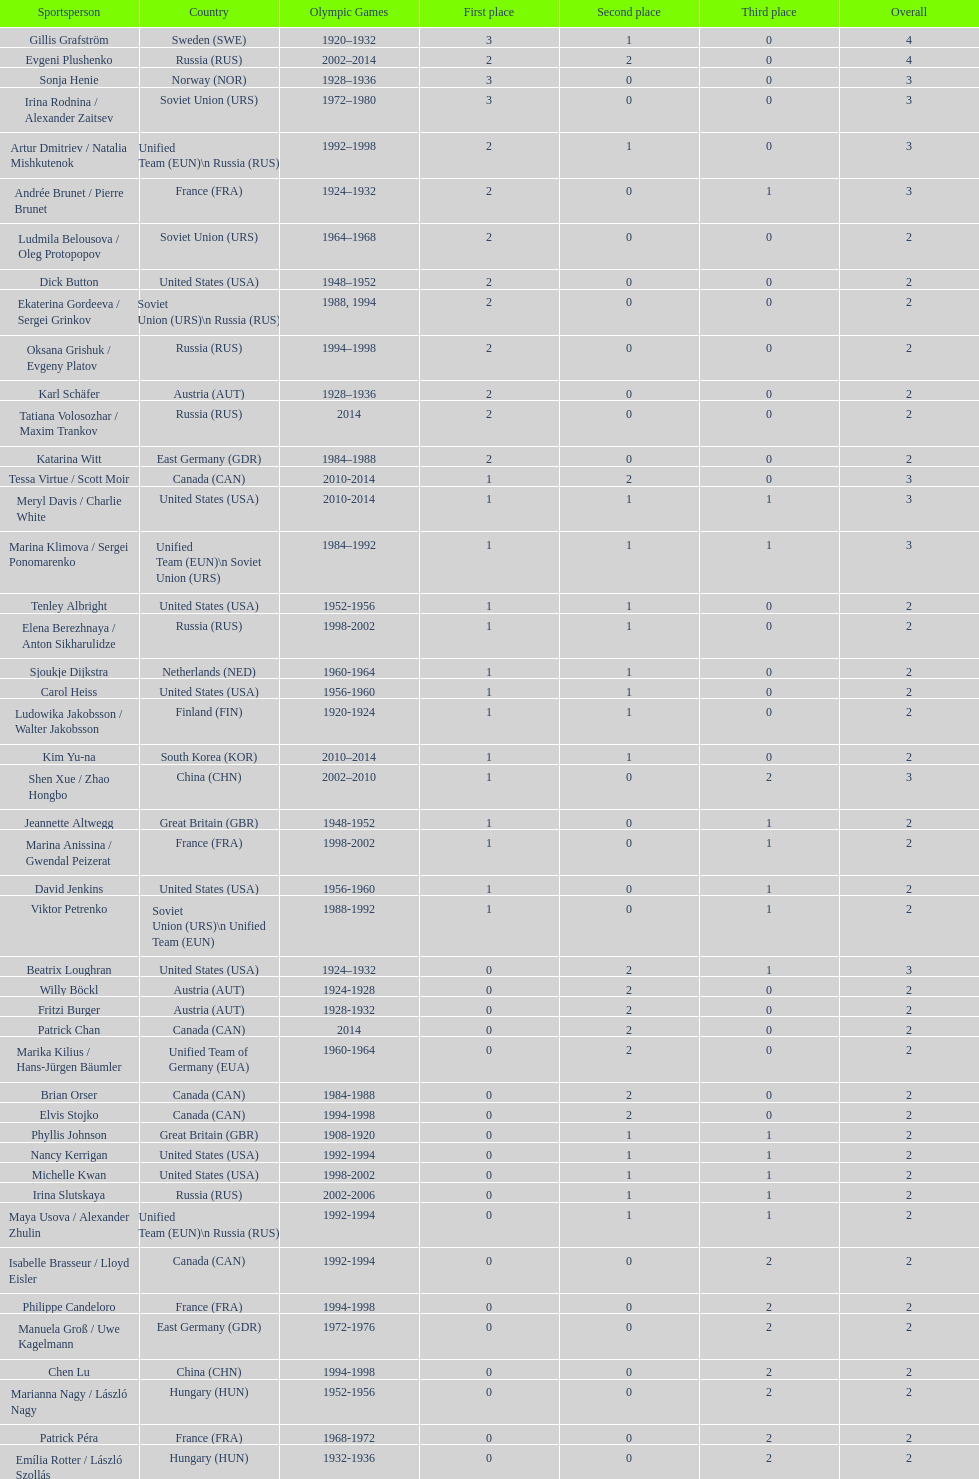How many silver medals did evgeni plushenko get? 2. 